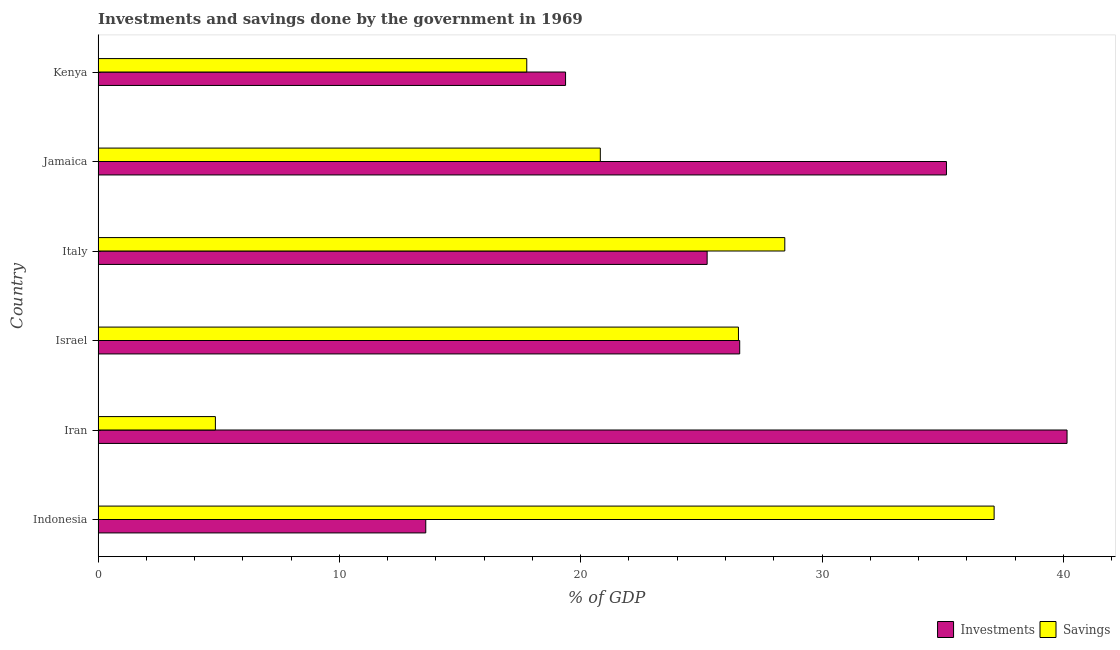How many different coloured bars are there?
Your response must be concise. 2. Are the number of bars on each tick of the Y-axis equal?
Your response must be concise. Yes. How many bars are there on the 1st tick from the top?
Your response must be concise. 2. What is the label of the 4th group of bars from the top?
Keep it short and to the point. Israel. What is the savings of government in Iran?
Make the answer very short. 4.86. Across all countries, what is the maximum savings of government?
Your answer should be very brief. 37.13. Across all countries, what is the minimum savings of government?
Ensure brevity in your answer.  4.86. In which country was the investments of government maximum?
Provide a succinct answer. Iran. In which country was the savings of government minimum?
Offer a very short reply. Iran. What is the total savings of government in the graph?
Offer a very short reply. 135.56. What is the difference between the investments of government in Indonesia and that in Jamaica?
Make the answer very short. -21.58. What is the difference between the savings of government in Indonesia and the investments of government in Italy?
Ensure brevity in your answer.  11.89. What is the average savings of government per country?
Provide a short and direct response. 22.59. What is the difference between the savings of government and investments of government in Israel?
Ensure brevity in your answer.  -0.05. What is the ratio of the investments of government in Iran to that in Israel?
Provide a succinct answer. 1.51. Is the savings of government in Iran less than that in Kenya?
Provide a succinct answer. Yes. What is the difference between the highest and the second highest savings of government?
Your response must be concise. 8.68. What is the difference between the highest and the lowest savings of government?
Offer a very short reply. 32.27. In how many countries, is the investments of government greater than the average investments of government taken over all countries?
Offer a terse response. 2. What does the 2nd bar from the top in Iran represents?
Your answer should be very brief. Investments. What does the 2nd bar from the bottom in Italy represents?
Offer a very short reply. Savings. How many bars are there?
Provide a succinct answer. 12. How many countries are there in the graph?
Provide a succinct answer. 6. Are the values on the major ticks of X-axis written in scientific E-notation?
Give a very brief answer. No. Does the graph contain any zero values?
Offer a very short reply. No. How many legend labels are there?
Your answer should be compact. 2. How are the legend labels stacked?
Your response must be concise. Horizontal. What is the title of the graph?
Give a very brief answer. Investments and savings done by the government in 1969. Does "Investment in Telecom" appear as one of the legend labels in the graph?
Give a very brief answer. No. What is the label or title of the X-axis?
Offer a terse response. % of GDP. What is the % of GDP in Investments in Indonesia?
Offer a very short reply. 13.58. What is the % of GDP of Savings in Indonesia?
Offer a terse response. 37.13. What is the % of GDP of Investments in Iran?
Offer a terse response. 40.15. What is the % of GDP of Savings in Iran?
Offer a terse response. 4.86. What is the % of GDP in Investments in Israel?
Offer a very short reply. 26.59. What is the % of GDP of Savings in Israel?
Offer a terse response. 26.54. What is the % of GDP in Investments in Italy?
Offer a very short reply. 25.24. What is the % of GDP in Savings in Italy?
Your response must be concise. 28.46. What is the % of GDP in Investments in Jamaica?
Your response must be concise. 35.16. What is the % of GDP in Savings in Jamaica?
Provide a succinct answer. 20.81. What is the % of GDP of Investments in Kenya?
Offer a terse response. 19.37. What is the % of GDP in Savings in Kenya?
Your response must be concise. 17.76. Across all countries, what is the maximum % of GDP in Investments?
Make the answer very short. 40.15. Across all countries, what is the maximum % of GDP of Savings?
Offer a terse response. 37.13. Across all countries, what is the minimum % of GDP of Investments?
Your response must be concise. 13.58. Across all countries, what is the minimum % of GDP of Savings?
Provide a succinct answer. 4.86. What is the total % of GDP of Investments in the graph?
Your answer should be compact. 160.09. What is the total % of GDP of Savings in the graph?
Provide a succinct answer. 135.56. What is the difference between the % of GDP in Investments in Indonesia and that in Iran?
Your answer should be very brief. -26.58. What is the difference between the % of GDP of Savings in Indonesia and that in Iran?
Your response must be concise. 32.27. What is the difference between the % of GDP of Investments in Indonesia and that in Israel?
Offer a terse response. -13.01. What is the difference between the % of GDP of Savings in Indonesia and that in Israel?
Provide a short and direct response. 10.6. What is the difference between the % of GDP in Investments in Indonesia and that in Italy?
Offer a terse response. -11.66. What is the difference between the % of GDP of Savings in Indonesia and that in Italy?
Make the answer very short. 8.67. What is the difference between the % of GDP in Investments in Indonesia and that in Jamaica?
Give a very brief answer. -21.58. What is the difference between the % of GDP of Savings in Indonesia and that in Jamaica?
Give a very brief answer. 16.32. What is the difference between the % of GDP in Investments in Indonesia and that in Kenya?
Offer a very short reply. -5.79. What is the difference between the % of GDP in Savings in Indonesia and that in Kenya?
Offer a terse response. 19.37. What is the difference between the % of GDP in Investments in Iran and that in Israel?
Your response must be concise. 13.57. What is the difference between the % of GDP in Savings in Iran and that in Israel?
Provide a short and direct response. -21.68. What is the difference between the % of GDP in Investments in Iran and that in Italy?
Keep it short and to the point. 14.92. What is the difference between the % of GDP of Savings in Iran and that in Italy?
Offer a terse response. -23.6. What is the difference between the % of GDP of Investments in Iran and that in Jamaica?
Keep it short and to the point. 5. What is the difference between the % of GDP in Savings in Iran and that in Jamaica?
Make the answer very short. -15.95. What is the difference between the % of GDP of Investments in Iran and that in Kenya?
Offer a terse response. 20.78. What is the difference between the % of GDP in Savings in Iran and that in Kenya?
Offer a very short reply. -12.9. What is the difference between the % of GDP in Investments in Israel and that in Italy?
Give a very brief answer. 1.35. What is the difference between the % of GDP of Savings in Israel and that in Italy?
Your answer should be compact. -1.92. What is the difference between the % of GDP of Investments in Israel and that in Jamaica?
Give a very brief answer. -8.57. What is the difference between the % of GDP in Savings in Israel and that in Jamaica?
Your answer should be very brief. 5.72. What is the difference between the % of GDP of Investments in Israel and that in Kenya?
Offer a very short reply. 7.22. What is the difference between the % of GDP in Savings in Israel and that in Kenya?
Make the answer very short. 8.77. What is the difference between the % of GDP of Investments in Italy and that in Jamaica?
Your answer should be compact. -9.92. What is the difference between the % of GDP of Savings in Italy and that in Jamaica?
Keep it short and to the point. 7.65. What is the difference between the % of GDP in Investments in Italy and that in Kenya?
Your response must be concise. 5.87. What is the difference between the % of GDP in Savings in Italy and that in Kenya?
Ensure brevity in your answer.  10.69. What is the difference between the % of GDP of Investments in Jamaica and that in Kenya?
Provide a succinct answer. 15.78. What is the difference between the % of GDP of Savings in Jamaica and that in Kenya?
Keep it short and to the point. 3.05. What is the difference between the % of GDP of Investments in Indonesia and the % of GDP of Savings in Iran?
Offer a very short reply. 8.72. What is the difference between the % of GDP in Investments in Indonesia and the % of GDP in Savings in Israel?
Your answer should be compact. -12.96. What is the difference between the % of GDP of Investments in Indonesia and the % of GDP of Savings in Italy?
Ensure brevity in your answer.  -14.88. What is the difference between the % of GDP in Investments in Indonesia and the % of GDP in Savings in Jamaica?
Your response must be concise. -7.23. What is the difference between the % of GDP in Investments in Indonesia and the % of GDP in Savings in Kenya?
Your response must be concise. -4.19. What is the difference between the % of GDP of Investments in Iran and the % of GDP of Savings in Israel?
Provide a succinct answer. 13.62. What is the difference between the % of GDP in Investments in Iran and the % of GDP in Savings in Italy?
Keep it short and to the point. 11.7. What is the difference between the % of GDP of Investments in Iran and the % of GDP of Savings in Jamaica?
Offer a very short reply. 19.34. What is the difference between the % of GDP of Investments in Iran and the % of GDP of Savings in Kenya?
Make the answer very short. 22.39. What is the difference between the % of GDP in Investments in Israel and the % of GDP in Savings in Italy?
Your response must be concise. -1.87. What is the difference between the % of GDP of Investments in Israel and the % of GDP of Savings in Jamaica?
Give a very brief answer. 5.78. What is the difference between the % of GDP of Investments in Israel and the % of GDP of Savings in Kenya?
Give a very brief answer. 8.82. What is the difference between the % of GDP of Investments in Italy and the % of GDP of Savings in Jamaica?
Provide a succinct answer. 4.43. What is the difference between the % of GDP in Investments in Italy and the % of GDP in Savings in Kenya?
Keep it short and to the point. 7.47. What is the difference between the % of GDP in Investments in Jamaica and the % of GDP in Savings in Kenya?
Provide a short and direct response. 17.39. What is the average % of GDP of Investments per country?
Offer a terse response. 26.68. What is the average % of GDP in Savings per country?
Your response must be concise. 22.59. What is the difference between the % of GDP of Investments and % of GDP of Savings in Indonesia?
Offer a terse response. -23.55. What is the difference between the % of GDP in Investments and % of GDP in Savings in Iran?
Keep it short and to the point. 35.29. What is the difference between the % of GDP of Investments and % of GDP of Savings in Israel?
Provide a succinct answer. 0.05. What is the difference between the % of GDP of Investments and % of GDP of Savings in Italy?
Make the answer very short. -3.22. What is the difference between the % of GDP in Investments and % of GDP in Savings in Jamaica?
Offer a terse response. 14.34. What is the difference between the % of GDP in Investments and % of GDP in Savings in Kenya?
Your answer should be very brief. 1.61. What is the ratio of the % of GDP of Investments in Indonesia to that in Iran?
Ensure brevity in your answer.  0.34. What is the ratio of the % of GDP of Savings in Indonesia to that in Iran?
Keep it short and to the point. 7.64. What is the ratio of the % of GDP of Investments in Indonesia to that in Israel?
Provide a short and direct response. 0.51. What is the ratio of the % of GDP in Savings in Indonesia to that in Israel?
Your response must be concise. 1.4. What is the ratio of the % of GDP in Investments in Indonesia to that in Italy?
Make the answer very short. 0.54. What is the ratio of the % of GDP in Savings in Indonesia to that in Italy?
Make the answer very short. 1.3. What is the ratio of the % of GDP of Investments in Indonesia to that in Jamaica?
Ensure brevity in your answer.  0.39. What is the ratio of the % of GDP in Savings in Indonesia to that in Jamaica?
Give a very brief answer. 1.78. What is the ratio of the % of GDP in Investments in Indonesia to that in Kenya?
Ensure brevity in your answer.  0.7. What is the ratio of the % of GDP in Savings in Indonesia to that in Kenya?
Provide a succinct answer. 2.09. What is the ratio of the % of GDP of Investments in Iran to that in Israel?
Ensure brevity in your answer.  1.51. What is the ratio of the % of GDP in Savings in Iran to that in Israel?
Your answer should be compact. 0.18. What is the ratio of the % of GDP of Investments in Iran to that in Italy?
Give a very brief answer. 1.59. What is the ratio of the % of GDP in Savings in Iran to that in Italy?
Keep it short and to the point. 0.17. What is the ratio of the % of GDP in Investments in Iran to that in Jamaica?
Offer a terse response. 1.14. What is the ratio of the % of GDP in Savings in Iran to that in Jamaica?
Your answer should be very brief. 0.23. What is the ratio of the % of GDP of Investments in Iran to that in Kenya?
Ensure brevity in your answer.  2.07. What is the ratio of the % of GDP in Savings in Iran to that in Kenya?
Make the answer very short. 0.27. What is the ratio of the % of GDP in Investments in Israel to that in Italy?
Ensure brevity in your answer.  1.05. What is the ratio of the % of GDP of Savings in Israel to that in Italy?
Provide a short and direct response. 0.93. What is the ratio of the % of GDP of Investments in Israel to that in Jamaica?
Offer a very short reply. 0.76. What is the ratio of the % of GDP of Savings in Israel to that in Jamaica?
Offer a very short reply. 1.28. What is the ratio of the % of GDP of Investments in Israel to that in Kenya?
Your answer should be compact. 1.37. What is the ratio of the % of GDP of Savings in Israel to that in Kenya?
Offer a very short reply. 1.49. What is the ratio of the % of GDP in Investments in Italy to that in Jamaica?
Offer a terse response. 0.72. What is the ratio of the % of GDP in Savings in Italy to that in Jamaica?
Offer a very short reply. 1.37. What is the ratio of the % of GDP in Investments in Italy to that in Kenya?
Keep it short and to the point. 1.3. What is the ratio of the % of GDP of Savings in Italy to that in Kenya?
Give a very brief answer. 1.6. What is the ratio of the % of GDP of Investments in Jamaica to that in Kenya?
Provide a succinct answer. 1.81. What is the ratio of the % of GDP in Savings in Jamaica to that in Kenya?
Give a very brief answer. 1.17. What is the difference between the highest and the second highest % of GDP in Investments?
Your response must be concise. 5. What is the difference between the highest and the second highest % of GDP of Savings?
Offer a very short reply. 8.67. What is the difference between the highest and the lowest % of GDP in Investments?
Provide a succinct answer. 26.58. What is the difference between the highest and the lowest % of GDP of Savings?
Offer a very short reply. 32.27. 